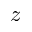Convert formula to latex. <formula><loc_0><loc_0><loc_500><loc_500>z</formula> 